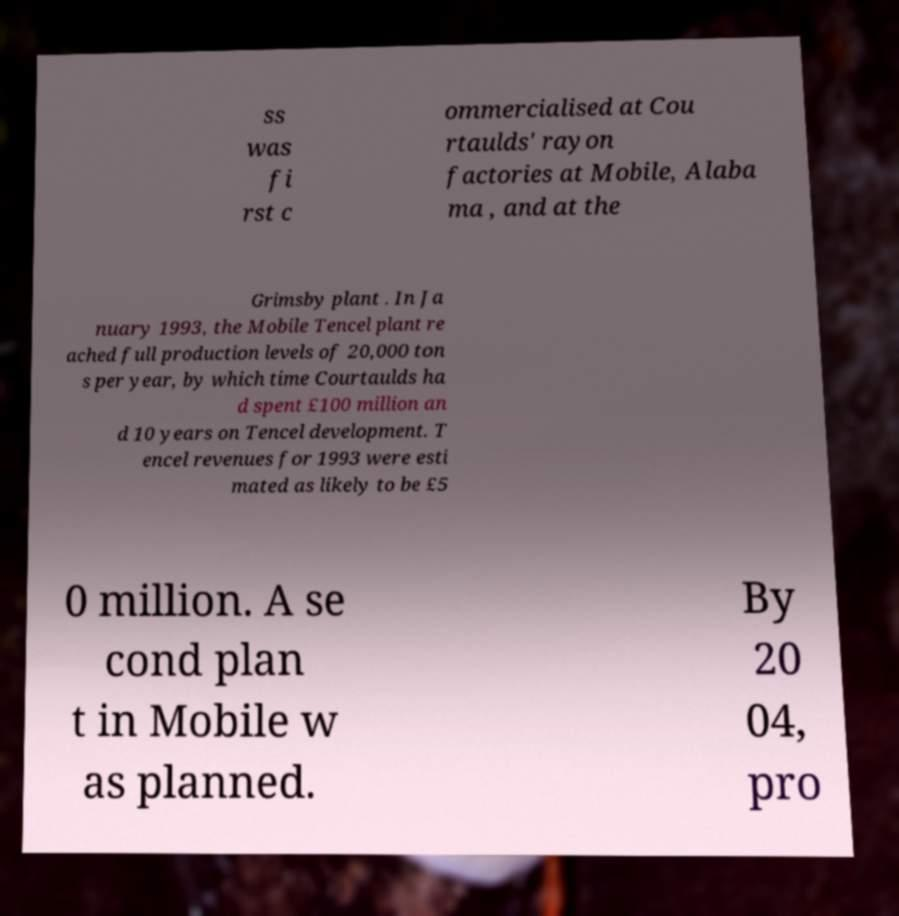Please read and relay the text visible in this image. What does it say? ss was fi rst c ommercialised at Cou rtaulds' rayon factories at Mobile, Alaba ma , and at the Grimsby plant . In Ja nuary 1993, the Mobile Tencel plant re ached full production levels of 20,000 ton s per year, by which time Courtaulds ha d spent £100 million an d 10 years on Tencel development. T encel revenues for 1993 were esti mated as likely to be £5 0 million. A se cond plan t in Mobile w as planned. By 20 04, pro 